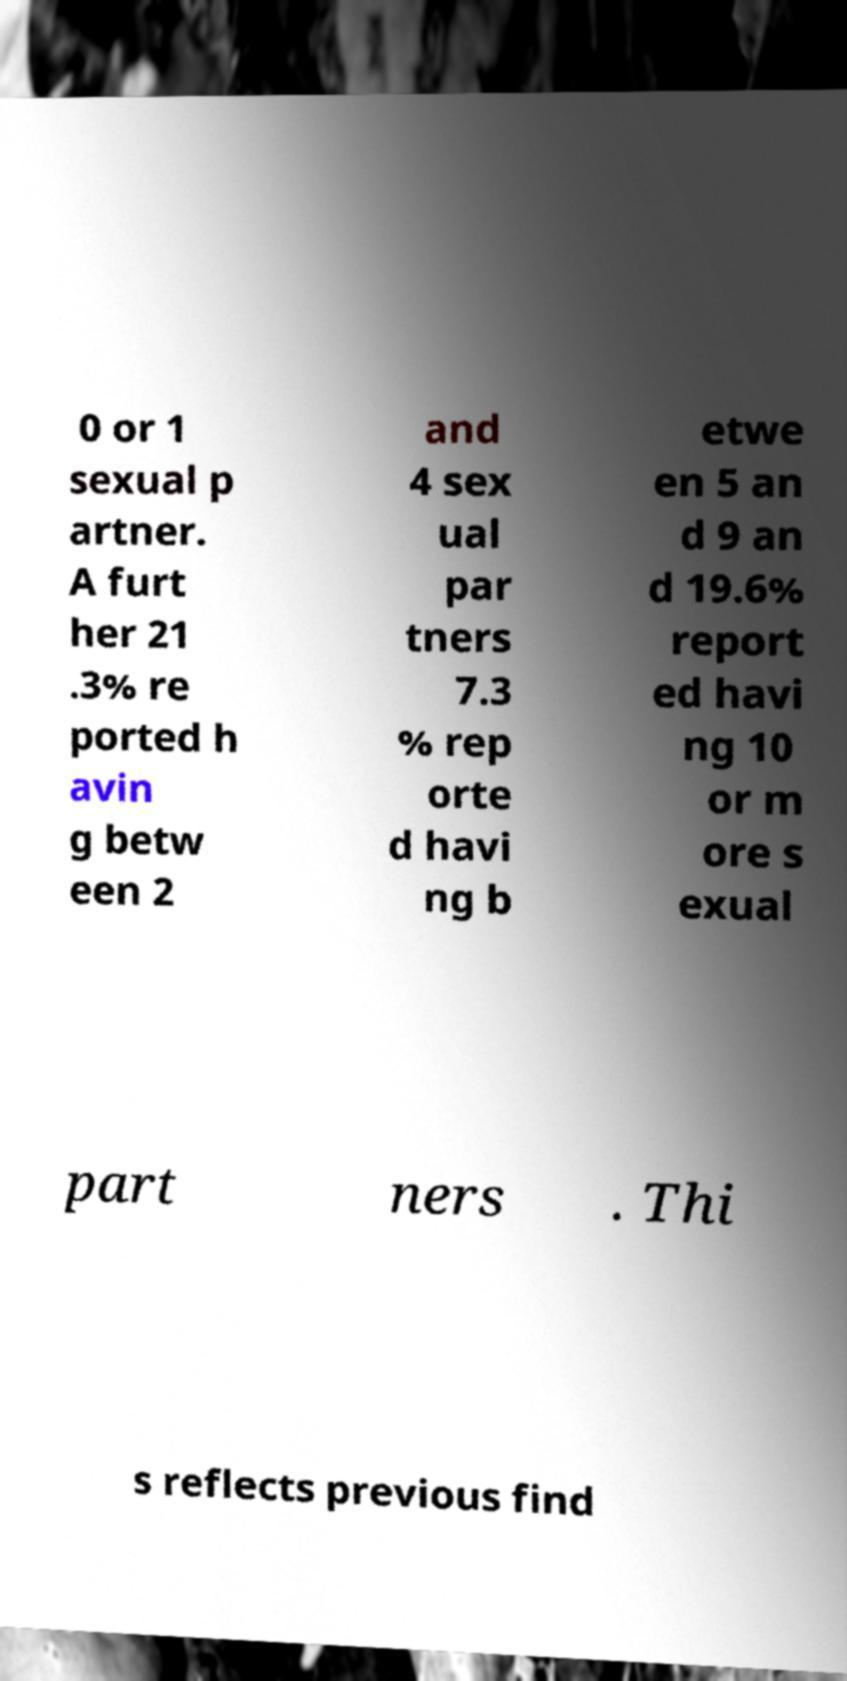Can you read and provide the text displayed in the image?This photo seems to have some interesting text. Can you extract and type it out for me? 0 or 1 sexual p artner. A furt her 21 .3% re ported h avin g betw een 2 and 4 sex ual par tners 7.3 % rep orte d havi ng b etwe en 5 an d 9 an d 19.6% report ed havi ng 10 or m ore s exual part ners . Thi s reflects previous find 